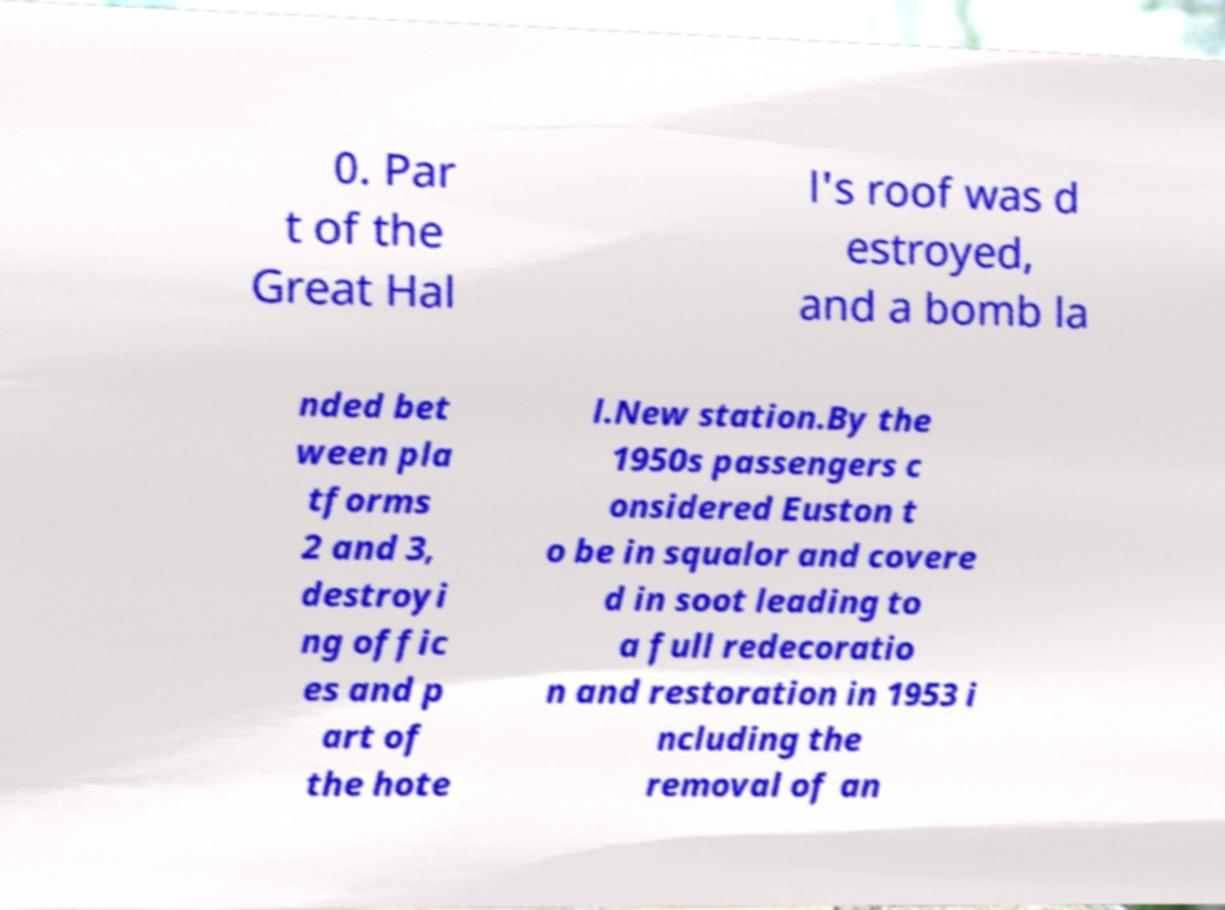Please read and relay the text visible in this image. What does it say? 0. Par t of the Great Hal l's roof was d estroyed, and a bomb la nded bet ween pla tforms 2 and 3, destroyi ng offic es and p art of the hote l.New station.By the 1950s passengers c onsidered Euston t o be in squalor and covere d in soot leading to a full redecoratio n and restoration in 1953 i ncluding the removal of an 